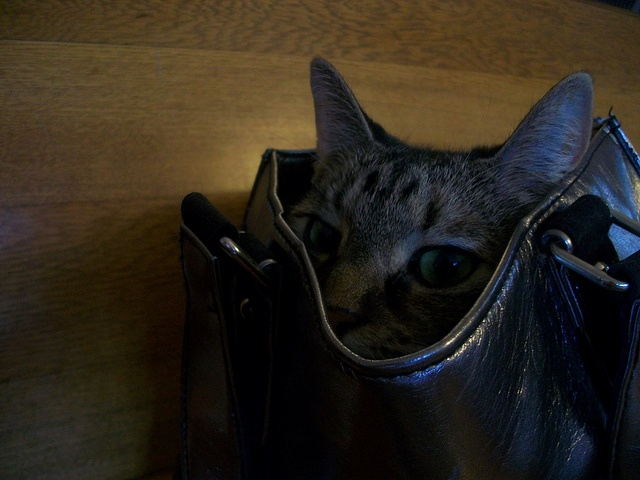Describe the objects in this image and their specific colors. I can see handbag in black, navy, gray, and darkblue tones and cat in black, darkblue, and gray tones in this image. 